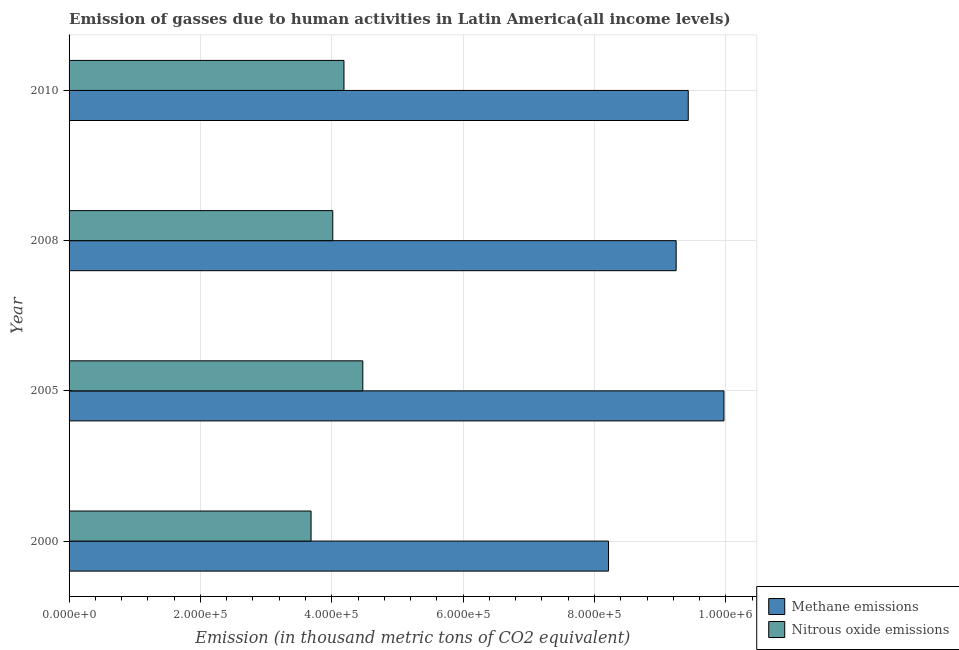Are the number of bars per tick equal to the number of legend labels?
Ensure brevity in your answer.  Yes. How many bars are there on the 2nd tick from the bottom?
Make the answer very short. 2. What is the label of the 4th group of bars from the top?
Your answer should be very brief. 2000. In how many cases, is the number of bars for a given year not equal to the number of legend labels?
Make the answer very short. 0. What is the amount of nitrous oxide emissions in 2010?
Offer a very short reply. 4.19e+05. Across all years, what is the maximum amount of methane emissions?
Ensure brevity in your answer.  9.97e+05. Across all years, what is the minimum amount of nitrous oxide emissions?
Provide a short and direct response. 3.68e+05. In which year was the amount of methane emissions maximum?
Provide a short and direct response. 2005. What is the total amount of methane emissions in the graph?
Make the answer very short. 3.69e+06. What is the difference between the amount of nitrous oxide emissions in 2000 and that in 2008?
Offer a very short reply. -3.31e+04. What is the difference between the amount of nitrous oxide emissions in 2000 and the amount of methane emissions in 2010?
Your answer should be compact. -5.74e+05. What is the average amount of methane emissions per year?
Offer a terse response. 9.21e+05. In the year 2000, what is the difference between the amount of methane emissions and amount of nitrous oxide emissions?
Your answer should be compact. 4.53e+05. In how many years, is the amount of nitrous oxide emissions greater than 240000 thousand metric tons?
Your response must be concise. 4. What is the ratio of the amount of nitrous oxide emissions in 2005 to that in 2008?
Keep it short and to the point. 1.11. Is the amount of methane emissions in 2008 less than that in 2010?
Provide a short and direct response. Yes. Is the difference between the amount of nitrous oxide emissions in 2000 and 2008 greater than the difference between the amount of methane emissions in 2000 and 2008?
Make the answer very short. Yes. What is the difference between the highest and the second highest amount of nitrous oxide emissions?
Your answer should be very brief. 2.87e+04. What is the difference between the highest and the lowest amount of methane emissions?
Make the answer very short. 1.76e+05. What does the 1st bar from the top in 2000 represents?
Ensure brevity in your answer.  Nitrous oxide emissions. What does the 2nd bar from the bottom in 2010 represents?
Your response must be concise. Nitrous oxide emissions. How many bars are there?
Your answer should be compact. 8. How many years are there in the graph?
Provide a short and direct response. 4. What is the difference between two consecutive major ticks on the X-axis?
Your answer should be very brief. 2.00e+05. Are the values on the major ticks of X-axis written in scientific E-notation?
Provide a succinct answer. Yes. Does the graph contain grids?
Make the answer very short. Yes. How are the legend labels stacked?
Keep it short and to the point. Vertical. What is the title of the graph?
Make the answer very short. Emission of gasses due to human activities in Latin America(all income levels). Does "Rural" appear as one of the legend labels in the graph?
Your response must be concise. No. What is the label or title of the X-axis?
Provide a short and direct response. Emission (in thousand metric tons of CO2 equivalent). What is the Emission (in thousand metric tons of CO2 equivalent) in Methane emissions in 2000?
Your response must be concise. 8.21e+05. What is the Emission (in thousand metric tons of CO2 equivalent) of Nitrous oxide emissions in 2000?
Provide a succinct answer. 3.68e+05. What is the Emission (in thousand metric tons of CO2 equivalent) of Methane emissions in 2005?
Offer a very short reply. 9.97e+05. What is the Emission (in thousand metric tons of CO2 equivalent) of Nitrous oxide emissions in 2005?
Make the answer very short. 4.47e+05. What is the Emission (in thousand metric tons of CO2 equivalent) in Methane emissions in 2008?
Give a very brief answer. 9.24e+05. What is the Emission (in thousand metric tons of CO2 equivalent) in Nitrous oxide emissions in 2008?
Give a very brief answer. 4.02e+05. What is the Emission (in thousand metric tons of CO2 equivalent) of Methane emissions in 2010?
Your answer should be compact. 9.43e+05. What is the Emission (in thousand metric tons of CO2 equivalent) in Nitrous oxide emissions in 2010?
Offer a terse response. 4.19e+05. Across all years, what is the maximum Emission (in thousand metric tons of CO2 equivalent) in Methane emissions?
Your answer should be very brief. 9.97e+05. Across all years, what is the maximum Emission (in thousand metric tons of CO2 equivalent) of Nitrous oxide emissions?
Offer a very short reply. 4.47e+05. Across all years, what is the minimum Emission (in thousand metric tons of CO2 equivalent) of Methane emissions?
Ensure brevity in your answer.  8.21e+05. Across all years, what is the minimum Emission (in thousand metric tons of CO2 equivalent) in Nitrous oxide emissions?
Provide a short and direct response. 3.68e+05. What is the total Emission (in thousand metric tons of CO2 equivalent) in Methane emissions in the graph?
Keep it short and to the point. 3.69e+06. What is the total Emission (in thousand metric tons of CO2 equivalent) of Nitrous oxide emissions in the graph?
Provide a succinct answer. 1.64e+06. What is the difference between the Emission (in thousand metric tons of CO2 equivalent) of Methane emissions in 2000 and that in 2005?
Your response must be concise. -1.76e+05. What is the difference between the Emission (in thousand metric tons of CO2 equivalent) of Nitrous oxide emissions in 2000 and that in 2005?
Ensure brevity in your answer.  -7.88e+04. What is the difference between the Emission (in thousand metric tons of CO2 equivalent) in Methane emissions in 2000 and that in 2008?
Offer a very short reply. -1.03e+05. What is the difference between the Emission (in thousand metric tons of CO2 equivalent) in Nitrous oxide emissions in 2000 and that in 2008?
Your answer should be very brief. -3.31e+04. What is the difference between the Emission (in thousand metric tons of CO2 equivalent) of Methane emissions in 2000 and that in 2010?
Your answer should be very brief. -1.21e+05. What is the difference between the Emission (in thousand metric tons of CO2 equivalent) of Nitrous oxide emissions in 2000 and that in 2010?
Give a very brief answer. -5.01e+04. What is the difference between the Emission (in thousand metric tons of CO2 equivalent) of Methane emissions in 2005 and that in 2008?
Your response must be concise. 7.28e+04. What is the difference between the Emission (in thousand metric tons of CO2 equivalent) in Nitrous oxide emissions in 2005 and that in 2008?
Keep it short and to the point. 4.57e+04. What is the difference between the Emission (in thousand metric tons of CO2 equivalent) of Methane emissions in 2005 and that in 2010?
Keep it short and to the point. 5.44e+04. What is the difference between the Emission (in thousand metric tons of CO2 equivalent) in Nitrous oxide emissions in 2005 and that in 2010?
Provide a succinct answer. 2.87e+04. What is the difference between the Emission (in thousand metric tons of CO2 equivalent) of Methane emissions in 2008 and that in 2010?
Your answer should be compact. -1.84e+04. What is the difference between the Emission (in thousand metric tons of CO2 equivalent) in Nitrous oxide emissions in 2008 and that in 2010?
Make the answer very short. -1.70e+04. What is the difference between the Emission (in thousand metric tons of CO2 equivalent) in Methane emissions in 2000 and the Emission (in thousand metric tons of CO2 equivalent) in Nitrous oxide emissions in 2005?
Provide a short and direct response. 3.74e+05. What is the difference between the Emission (in thousand metric tons of CO2 equivalent) in Methane emissions in 2000 and the Emission (in thousand metric tons of CO2 equivalent) in Nitrous oxide emissions in 2008?
Ensure brevity in your answer.  4.20e+05. What is the difference between the Emission (in thousand metric tons of CO2 equivalent) of Methane emissions in 2000 and the Emission (in thousand metric tons of CO2 equivalent) of Nitrous oxide emissions in 2010?
Offer a very short reply. 4.03e+05. What is the difference between the Emission (in thousand metric tons of CO2 equivalent) of Methane emissions in 2005 and the Emission (in thousand metric tons of CO2 equivalent) of Nitrous oxide emissions in 2008?
Your answer should be very brief. 5.96e+05. What is the difference between the Emission (in thousand metric tons of CO2 equivalent) in Methane emissions in 2005 and the Emission (in thousand metric tons of CO2 equivalent) in Nitrous oxide emissions in 2010?
Give a very brief answer. 5.79e+05. What is the difference between the Emission (in thousand metric tons of CO2 equivalent) in Methane emissions in 2008 and the Emission (in thousand metric tons of CO2 equivalent) in Nitrous oxide emissions in 2010?
Keep it short and to the point. 5.06e+05. What is the average Emission (in thousand metric tons of CO2 equivalent) in Methane emissions per year?
Provide a succinct answer. 9.21e+05. What is the average Emission (in thousand metric tons of CO2 equivalent) of Nitrous oxide emissions per year?
Your response must be concise. 4.09e+05. In the year 2000, what is the difference between the Emission (in thousand metric tons of CO2 equivalent) in Methane emissions and Emission (in thousand metric tons of CO2 equivalent) in Nitrous oxide emissions?
Provide a succinct answer. 4.53e+05. In the year 2005, what is the difference between the Emission (in thousand metric tons of CO2 equivalent) of Methane emissions and Emission (in thousand metric tons of CO2 equivalent) of Nitrous oxide emissions?
Provide a short and direct response. 5.50e+05. In the year 2008, what is the difference between the Emission (in thousand metric tons of CO2 equivalent) of Methane emissions and Emission (in thousand metric tons of CO2 equivalent) of Nitrous oxide emissions?
Provide a short and direct response. 5.23e+05. In the year 2010, what is the difference between the Emission (in thousand metric tons of CO2 equivalent) in Methane emissions and Emission (in thousand metric tons of CO2 equivalent) in Nitrous oxide emissions?
Give a very brief answer. 5.24e+05. What is the ratio of the Emission (in thousand metric tons of CO2 equivalent) of Methane emissions in 2000 to that in 2005?
Offer a terse response. 0.82. What is the ratio of the Emission (in thousand metric tons of CO2 equivalent) in Nitrous oxide emissions in 2000 to that in 2005?
Provide a succinct answer. 0.82. What is the ratio of the Emission (in thousand metric tons of CO2 equivalent) of Methane emissions in 2000 to that in 2008?
Offer a very short reply. 0.89. What is the ratio of the Emission (in thousand metric tons of CO2 equivalent) of Nitrous oxide emissions in 2000 to that in 2008?
Offer a very short reply. 0.92. What is the ratio of the Emission (in thousand metric tons of CO2 equivalent) of Methane emissions in 2000 to that in 2010?
Give a very brief answer. 0.87. What is the ratio of the Emission (in thousand metric tons of CO2 equivalent) in Nitrous oxide emissions in 2000 to that in 2010?
Your response must be concise. 0.88. What is the ratio of the Emission (in thousand metric tons of CO2 equivalent) of Methane emissions in 2005 to that in 2008?
Offer a very short reply. 1.08. What is the ratio of the Emission (in thousand metric tons of CO2 equivalent) in Nitrous oxide emissions in 2005 to that in 2008?
Keep it short and to the point. 1.11. What is the ratio of the Emission (in thousand metric tons of CO2 equivalent) in Methane emissions in 2005 to that in 2010?
Keep it short and to the point. 1.06. What is the ratio of the Emission (in thousand metric tons of CO2 equivalent) of Nitrous oxide emissions in 2005 to that in 2010?
Make the answer very short. 1.07. What is the ratio of the Emission (in thousand metric tons of CO2 equivalent) in Methane emissions in 2008 to that in 2010?
Your response must be concise. 0.98. What is the ratio of the Emission (in thousand metric tons of CO2 equivalent) of Nitrous oxide emissions in 2008 to that in 2010?
Your answer should be compact. 0.96. What is the difference between the highest and the second highest Emission (in thousand metric tons of CO2 equivalent) of Methane emissions?
Keep it short and to the point. 5.44e+04. What is the difference between the highest and the second highest Emission (in thousand metric tons of CO2 equivalent) in Nitrous oxide emissions?
Offer a terse response. 2.87e+04. What is the difference between the highest and the lowest Emission (in thousand metric tons of CO2 equivalent) in Methane emissions?
Keep it short and to the point. 1.76e+05. What is the difference between the highest and the lowest Emission (in thousand metric tons of CO2 equivalent) in Nitrous oxide emissions?
Make the answer very short. 7.88e+04. 